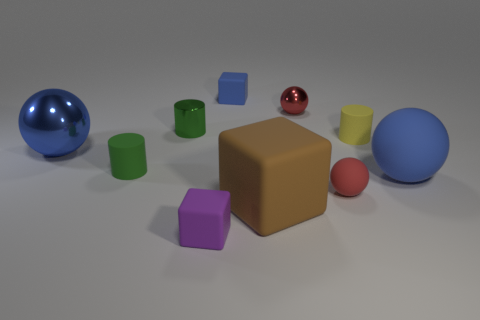Subtract all blue balls. How many were subtracted if there are1blue balls left? 1 Subtract all spheres. How many objects are left? 6 Add 2 small balls. How many small balls exist? 4 Subtract 1 green cylinders. How many objects are left? 9 Subtract all large brown rubber cubes. Subtract all red objects. How many objects are left? 7 Add 1 red rubber things. How many red rubber things are left? 2 